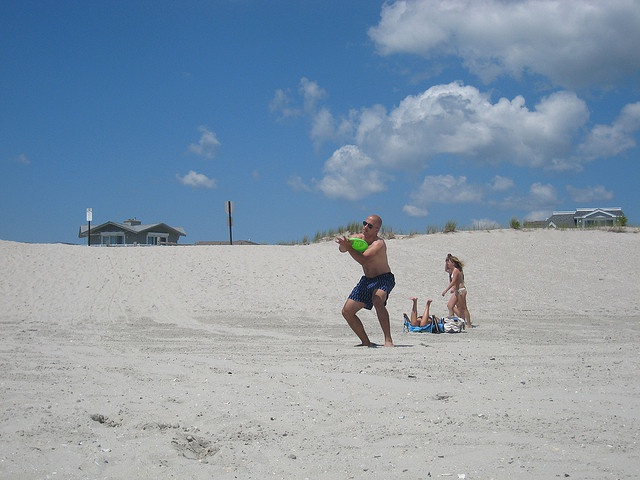Describe the objects in this image and their specific colors. I can see people in blue, brown, black, and maroon tones, people in blue, gray, darkgray, and maroon tones, people in blue, gray, darkgray, and tan tones, handbag in blue, darkgray, gray, lightgray, and black tones, and frisbee in blue, green, and darkgreen tones in this image. 